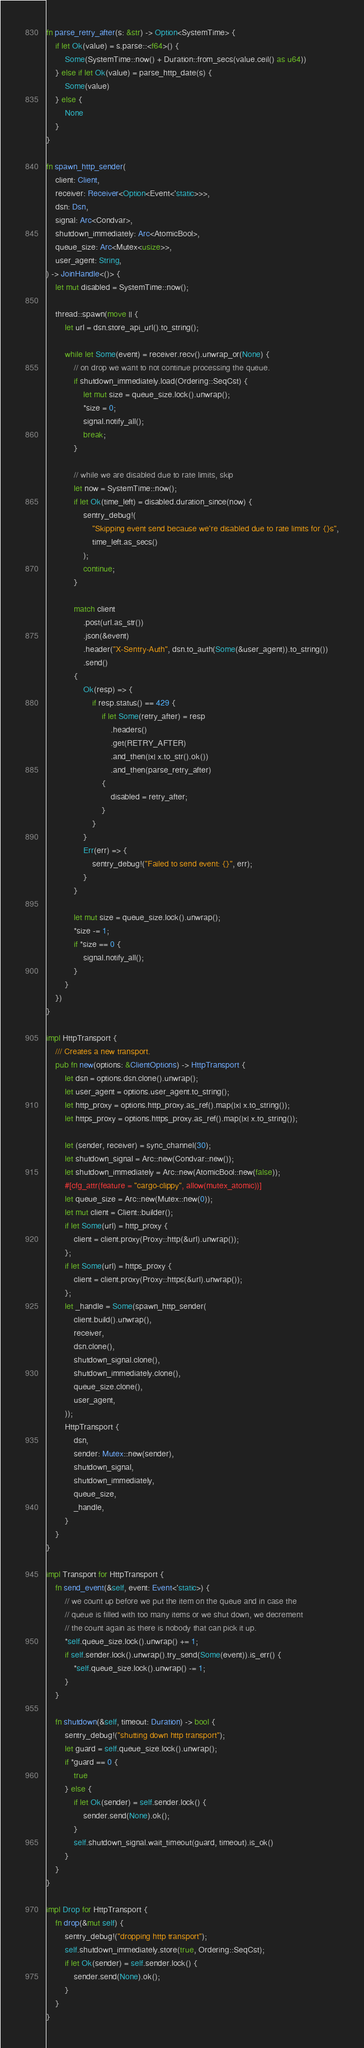<code> <loc_0><loc_0><loc_500><loc_500><_Rust_>fn parse_retry_after(s: &str) -> Option<SystemTime> {
    if let Ok(value) = s.parse::<f64>() {
        Some(SystemTime::now() + Duration::from_secs(value.ceil() as u64))
    } else if let Ok(value) = parse_http_date(s) {
        Some(value)
    } else {
        None
    }
}

fn spawn_http_sender(
    client: Client,
    receiver: Receiver<Option<Event<'static>>>,
    dsn: Dsn,
    signal: Arc<Condvar>,
    shutdown_immediately: Arc<AtomicBool>,
    queue_size: Arc<Mutex<usize>>,
    user_agent: String,
) -> JoinHandle<()> {
    let mut disabled = SystemTime::now();

    thread::spawn(move || {
        let url = dsn.store_api_url().to_string();

        while let Some(event) = receiver.recv().unwrap_or(None) {
            // on drop we want to not continue processing the queue.
            if shutdown_immediately.load(Ordering::SeqCst) {
                let mut size = queue_size.lock().unwrap();
                *size = 0;
                signal.notify_all();
                break;
            }

            // while we are disabled due to rate limits, skip
            let now = SystemTime::now();
            if let Ok(time_left) = disabled.duration_since(now) {
                sentry_debug!(
                    "Skipping event send because we're disabled due to rate limits for {}s",
                    time_left.as_secs()
                );
                continue;
            }

            match client
                .post(url.as_str())
                .json(&event)
                .header("X-Sentry-Auth", dsn.to_auth(Some(&user_agent)).to_string())
                .send()
            {
                Ok(resp) => {
                    if resp.status() == 429 {
                        if let Some(retry_after) = resp
                            .headers()
                            .get(RETRY_AFTER)
                            .and_then(|x| x.to_str().ok())
                            .and_then(parse_retry_after)
                        {
                            disabled = retry_after;
                        }
                    }
                }
                Err(err) => {
                    sentry_debug!("Failed to send event: {}", err);
                }
            }

            let mut size = queue_size.lock().unwrap();
            *size -= 1;
            if *size == 0 {
                signal.notify_all();
            }
        }
    })
}

impl HttpTransport {
    /// Creates a new transport.
    pub fn new(options: &ClientOptions) -> HttpTransport {
        let dsn = options.dsn.clone().unwrap();
        let user_agent = options.user_agent.to_string();
        let http_proxy = options.http_proxy.as_ref().map(|x| x.to_string());
        let https_proxy = options.https_proxy.as_ref().map(|x| x.to_string());

        let (sender, receiver) = sync_channel(30);
        let shutdown_signal = Arc::new(Condvar::new());
        let shutdown_immediately = Arc::new(AtomicBool::new(false));
        #[cfg_attr(feature = "cargo-clippy", allow(mutex_atomic))]
        let queue_size = Arc::new(Mutex::new(0));
        let mut client = Client::builder();
        if let Some(url) = http_proxy {
            client = client.proxy(Proxy::http(&url).unwrap());
        };
        if let Some(url) = https_proxy {
            client = client.proxy(Proxy::https(&url).unwrap());
        };
        let _handle = Some(spawn_http_sender(
            client.build().unwrap(),
            receiver,
            dsn.clone(),
            shutdown_signal.clone(),
            shutdown_immediately.clone(),
            queue_size.clone(),
            user_agent,
        ));
        HttpTransport {
            dsn,
            sender: Mutex::new(sender),
            shutdown_signal,
            shutdown_immediately,
            queue_size,
            _handle,
        }
    }
}

impl Transport for HttpTransport {
    fn send_event(&self, event: Event<'static>) {
        // we count up before we put the item on the queue and in case the
        // queue is filled with too many items or we shut down, we decrement
        // the count again as there is nobody that can pick it up.
        *self.queue_size.lock().unwrap() += 1;
        if self.sender.lock().unwrap().try_send(Some(event)).is_err() {
            *self.queue_size.lock().unwrap() -= 1;
        }
    }

    fn shutdown(&self, timeout: Duration) -> bool {
        sentry_debug!("shutting down http transport");
        let guard = self.queue_size.lock().unwrap();
        if *guard == 0 {
            true
        } else {
            if let Ok(sender) = self.sender.lock() {
                sender.send(None).ok();
            }
            self.shutdown_signal.wait_timeout(guard, timeout).is_ok()
        }
    }
}

impl Drop for HttpTransport {
    fn drop(&mut self) {
        sentry_debug!("dropping http transport");
        self.shutdown_immediately.store(true, Ordering::SeqCst);
        if let Ok(sender) = self.sender.lock() {
            sender.send(None).ok();
        }
    }
}
</code> 